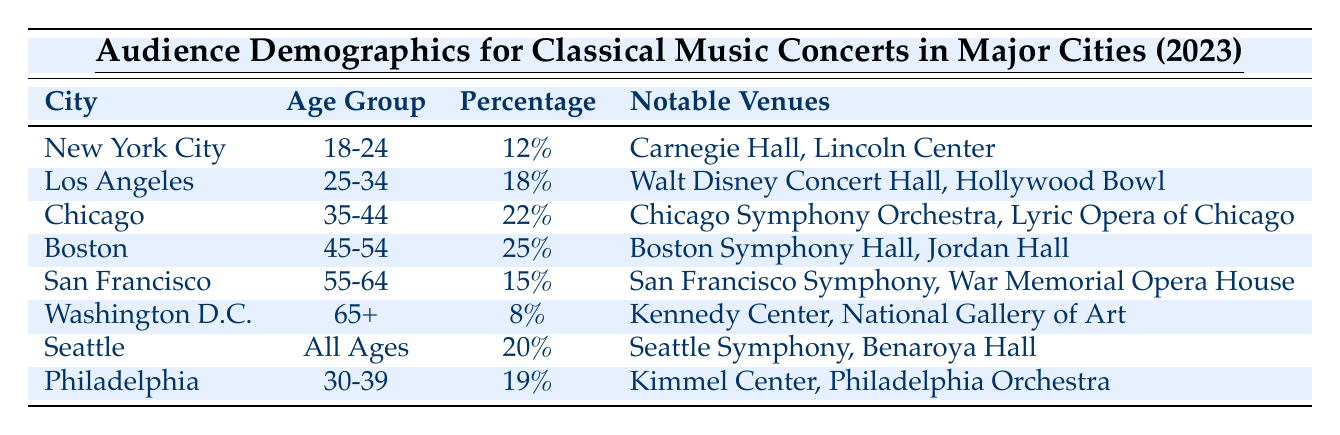What percentage of the audience in Boston is aged 45-54? The table indicates that in Boston, the age group 45-54 has a percentage of 25% listed under the "Percentage" column.
Answer: 25% Which city has the youngest audience demographic? New York City has the demographic of 18-24 years with a percentage of 12%, making it the oldest demographic, while the age group 65+ in Washington D.C. has the lowest percentage of 8%.
Answer: New York City What are the notable venues for the age group of 65 and older? According to the table, Washington D.C. is the city with the age group of 65+, and its notable venues are the Kennedy Center and the National Gallery of Art.
Answer: Kennedy Center, National Gallery of Art How does the percentage of 25-34 year-olds in Los Angeles compare to the percentage of 35-44 year-olds in Chicago? Los Angeles has 18% for the age group 25-34, while Chicago has 22% for the age group 35-44. To find out the difference: 22% - 18% = 4%. Therefore, Chicago has a higher percentage by 4%.
Answer: 4% What is the total percentage of concertgoers aged 25-34 and 30-39 across Los Angeles and Philadelphia? In Los Angeles, the percentage for 25-34 is 18%, and in Philadelphia, it's 19% for 30-39. Adding these gives: 18% + 19% = 37%.
Answer: 37% Is there a city where all ages are represented? Yes, according to the table, Seattle represents an audience demographic of "All Ages" with a percentage of 20%.
Answer: Yes Which age group constitutes the largest audience demographic in any major city from the table? The table shows that Boston has the largest demographic with 25% for the age group 45-54, making it the highest percentage among the listed cities.
Answer: 45-54 (25%) Which city has the lowest percentage of concertgoers in any age group? The table indicates the lowest percentage is in Washington D.C. for the age group 65+, which is 8%.
Answer: Washington D.C. (8%) If you were to combine the percentages of all age groups from the cities of New York City and San Francisco, what would it be? New York City has 12% for 18-24, and San Francisco has 15% for 55-64. Adding these gives: 12% + 15% = 27%.
Answer: 27% What age group has the highest percentage in the table? Boston's age group of 45-54 has the highest percentage at 25%, making it the highest among all age groups in the table.
Answer: 45-54 (25%) 